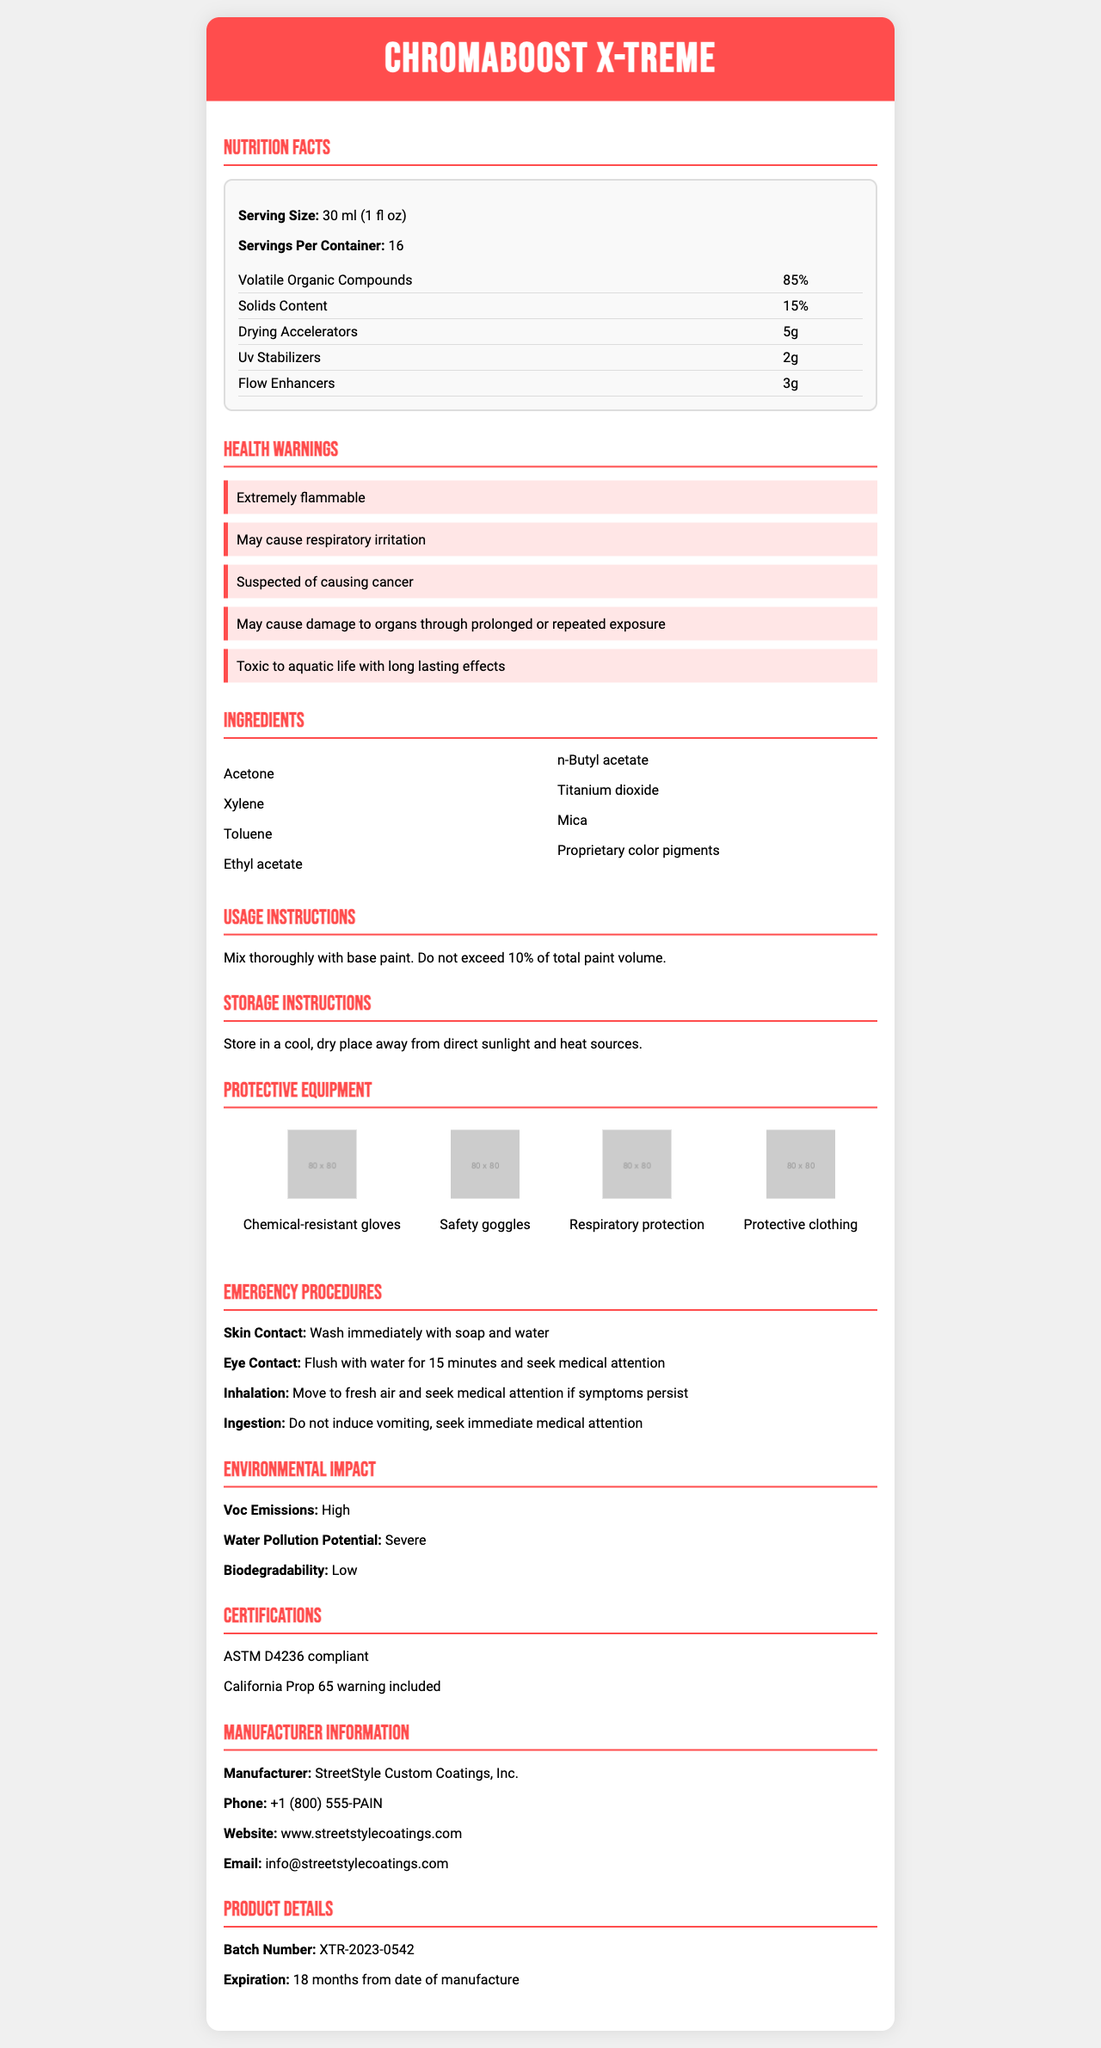what is the serving size of ChromaBoost X-Treme? The serving size is listed in the Nutrition Facts section of the document.
Answer: 30 ml (1 fl oz) how many servings are in one container of ChromaBoost X-Treme? The servings per container are mentioned right after the serving size in the Nutrition Facts section.
Answer: 16 what are the main volatile organic compounds (VOCs) percentages in ChromaBoost X-Treme? The volatile organic compounds percentage is listed as 85% in the Nutrition Facts section.
Answer: 85% which ingredient is responsible for the color pigments? "Proprietary color pigments" is listed as one of the ingredients, making it responsible for the color pigments.
Answer: Proprietary color pigments list any three protective equipment recommended for using ChromaBoost X-Treme. The Protective Equipment section lists various protective gears including Chemical-resistant gloves, Safety goggles, and Respiratory protection.
Answer: Chemical-resistant gloves, Safety goggles, Respiratory protection what are the instructions for mixing ChromaBoost X-Treme? A. Mix thoroughly with base paint. Do not exceed 20% of total paint volume. B. Mix thoroughly with base paint. Do not exceed 10% of total paint volume. C. Mix with water. Do not exceed 10% of total paint volume. The Usage Instructions section states: "Mix thoroughly with base paint. Do not exceed 10% of total paint volume."
Answer: B which of the following is NOT a health warning listed for ChromaBoost X-Treme? 1. Extremely flammable 2. May cause respiratory irritation 3. Harmful to pets 4. Suspected of causing cancer The document lists Extremely flammable, May cause respiratory irritation, and Suspected of causing cancer, but there is no mention of it being harmful to pets.
Answer: 3 is ChromaBoost X-Treme safe for aquatic life? The health warnings section mentions that the product is "Toxic to aquatic life with long lasting effects."
Answer: No how should ChromaBoost X-Treme be stored? The Storage Instructions section advises storing the product in a cool, dry place away from direct sunlight and heat sources.
Answer: Store in a cool, dry place away from direct sunlight and heat sources. what should be done in case of eye contact with ChromaBoost X-Treme? The Emergency Procedures section mentions: "For eye contact: Flush with water for 15 minutes and seek medical attention."
Answer: Flush with water for 15 minutes and seek medical attention summarize the main theme of the ChromaBoost X-Treme document. This summary encompasses the key aspects of the document, providing an overview of the product details and safety measures.
Answer: ChromaBoost X-Treme is a custom-blended paint additive designed for vehicle customization. The document provides detailed nutrition facts, lists the ingredients, health warnings, proper usage and storage instructions, recommended protective equipment, emergency procedures, environmental impact concerns, and manufacturer information, emphasizing safety and handling considerably. what is the exact biodegradability percentage of ChromaBoost X-Treme? The document mentions that the biodegradability of ChromaBoost X-Treme is "Low," but does not provide an exact percentage.
Answer: Not enough information 